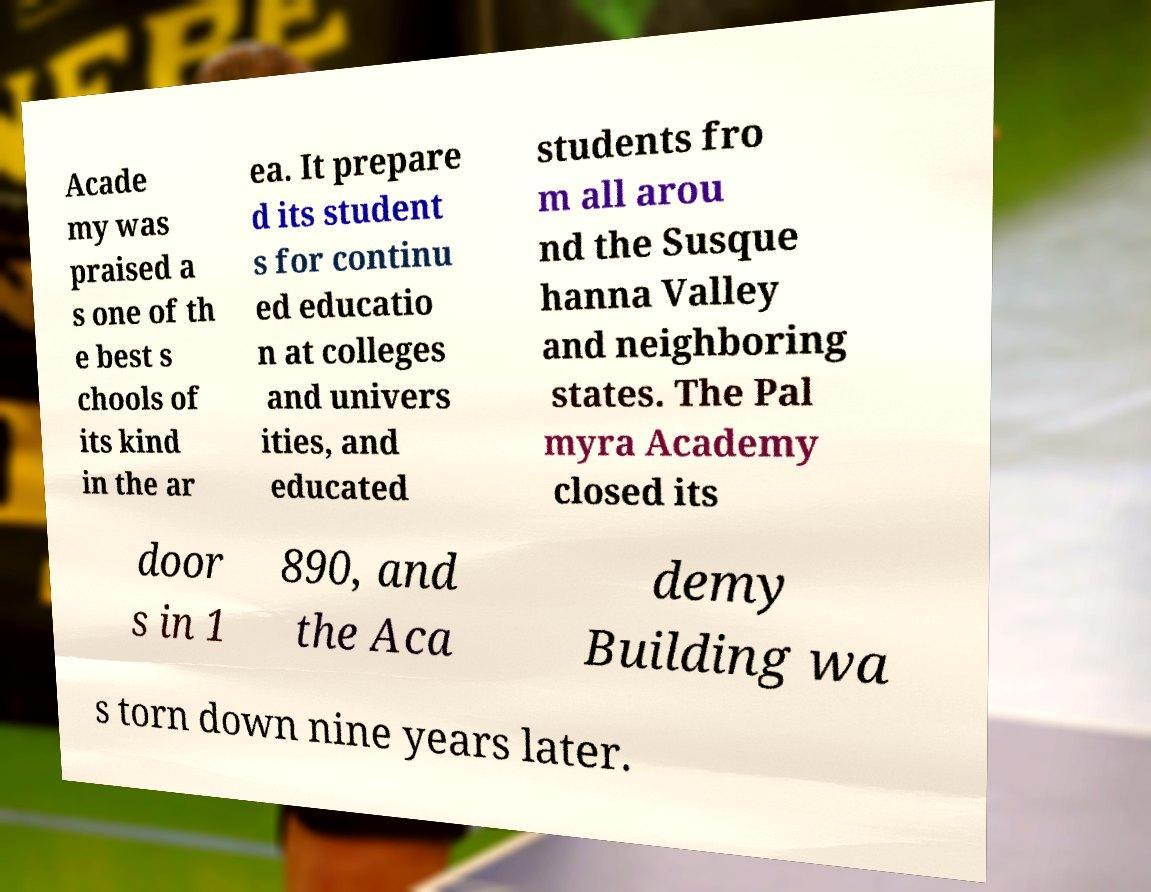Please identify and transcribe the text found in this image. Acade my was praised a s one of th e best s chools of its kind in the ar ea. It prepare d its student s for continu ed educatio n at colleges and univers ities, and educated students fro m all arou nd the Susque hanna Valley and neighboring states. The Pal myra Academy closed its door s in 1 890, and the Aca demy Building wa s torn down nine years later. 